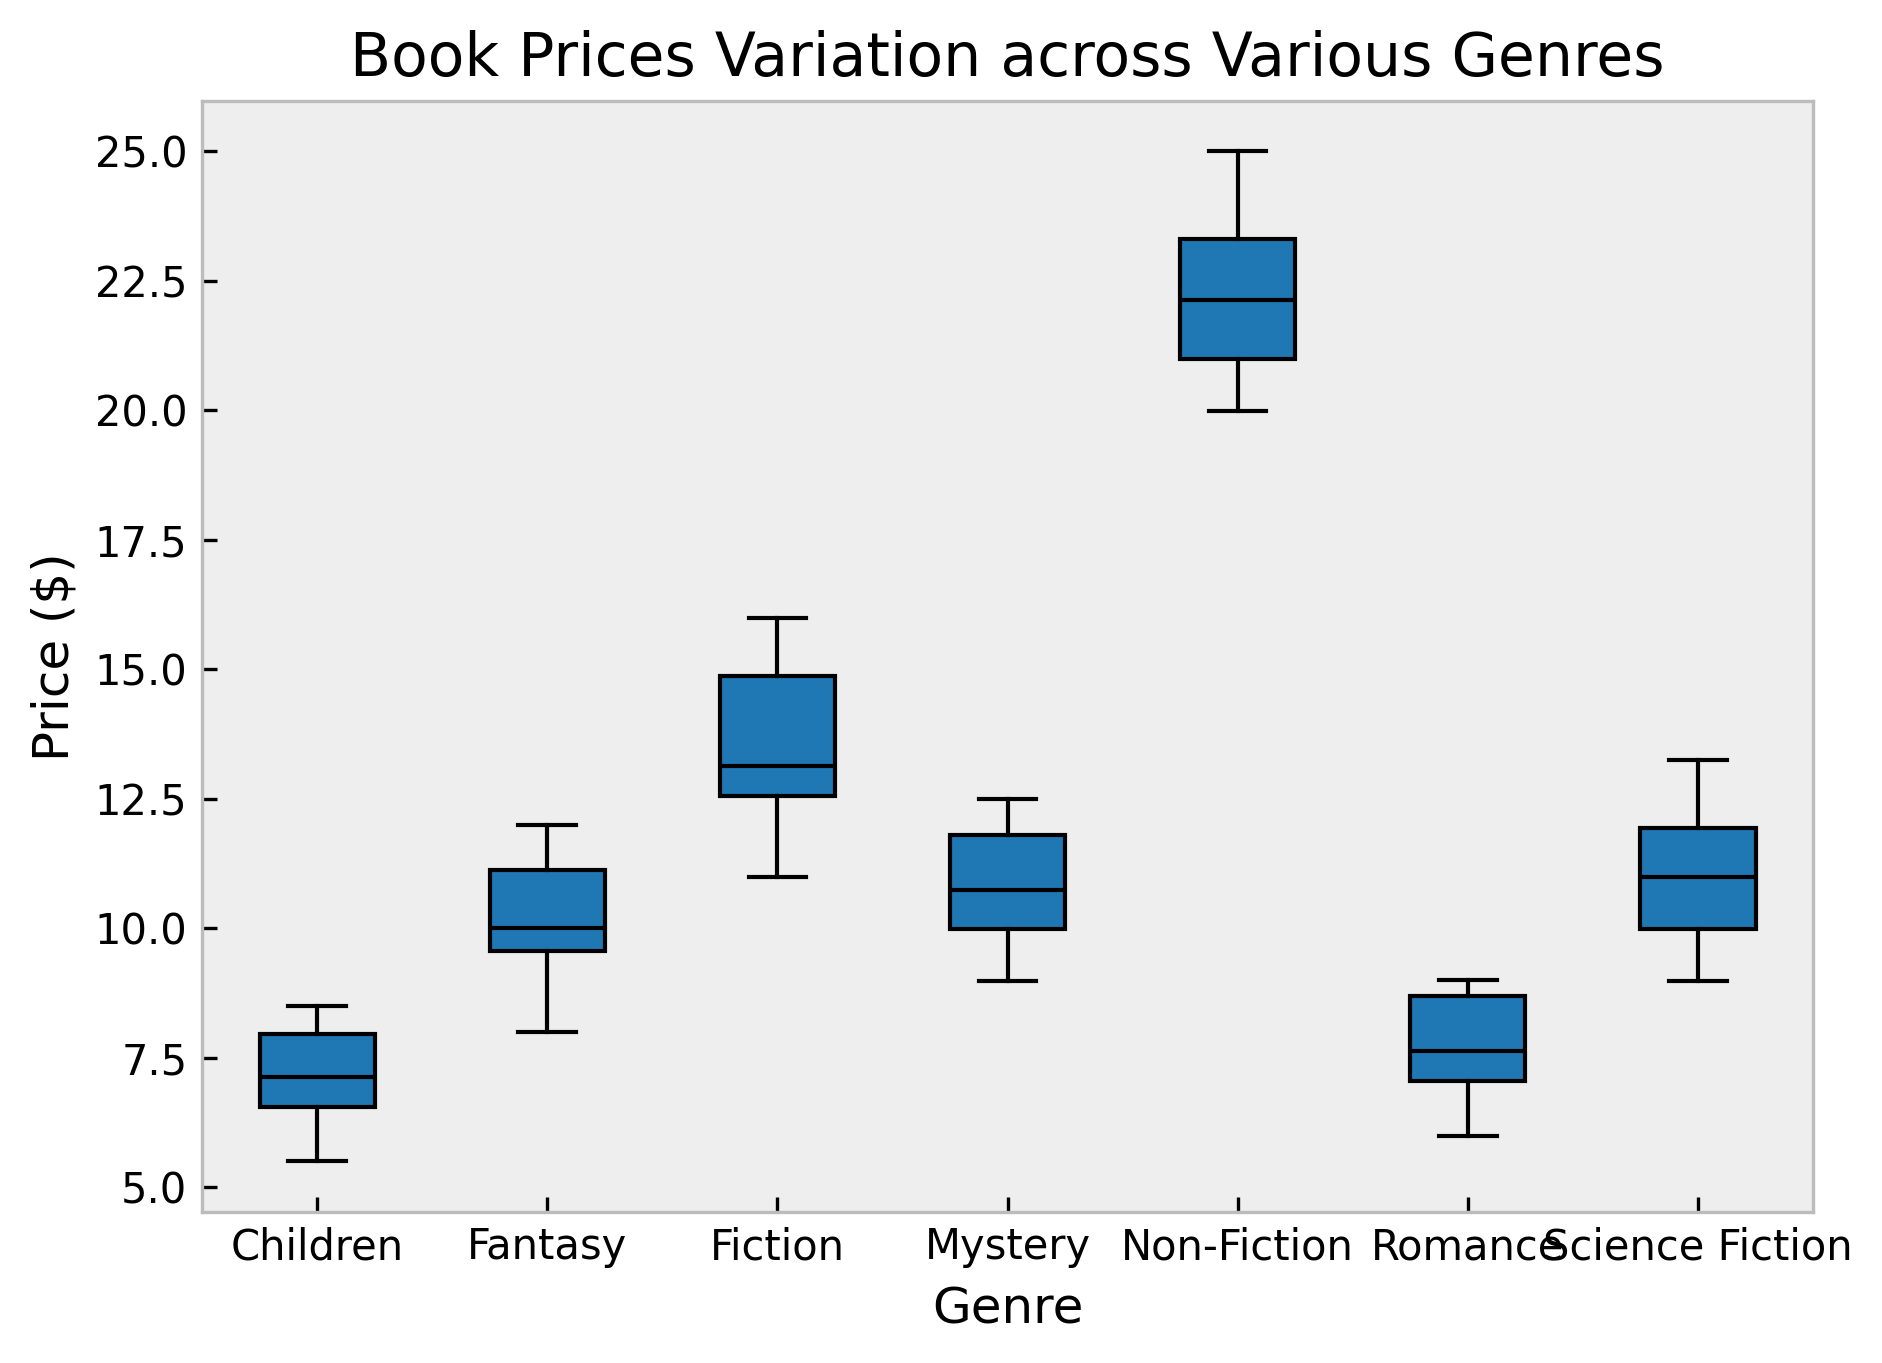What is the median price of children's books? The median price is the middle value of a sorted list of numbers. For children's books, sort the prices and find the middle value. The sorted prices are 5.50, 5.99, 6.49, 6.75, 6.99, 7.25, 7.85, 7.99, 8.00, 8.50. The median value is between the 5th and 6th values: (6.99 + 7.25) / 2 = 7.12.
Answer: 7.12 Which genre has the highest median book price? To find the highest median book price, look at the middle line of each box, which represents the median. For Non-Fiction, the line is highest, indicating the highest median price.
Answer: Non-Fiction Compare the range of book prices for Mystery and Fantasy genres. Which one has a greater range? The range is the difference between the maximum and minimum values. For Mystery, range = 12.49 - 8.99 = 3.50. For Fantasy, range = 12.00 - 7.99 = 4.01. Fantasy has a greater range.
Answer: Fantasy Is there any genre with outliers in the book prices? Outliers are often indicated by points outside the whiskers of the box plots. Looking at the figures, no genre shows outliers (points outside the main box plot range).
Answer: No What is the interquartile range (IQR) for Fiction books? IQR is calculated by subtracting the first quartile (Q1) from the third quartile (Q3). For Fiction: locate Q1 and Q3 from the box. Q1 is approximately 12.25 and Q3 is about 14.99. So, IQR is (14.99 - 12.25) = 2.74.
Answer: 2.74 Which genre has the smallest variation in book prices? Variation can be visually assessed by the height of the box in the box plot. The shorter the box, the smaller the variation. Children's genre has the shortest box, indicating the smallest variation.
Answer: Children Between Science Fiction and Romance genres, which has a higher maximum price? The maximum price is indicated by the top whisker or edge of the box. For Science Fiction, the top whisker is at 13.25, while for Romance, it is at 9.00. Hence, Science Fiction has a higher maximum price.
Answer: Science Fiction How many genres have a median price greater than $10? Check the middle line (median) of each genre's box in the plot. Genres with median prices above $10 are Fiction, Non-Fiction, Science Fiction, and Mystery. In total, there are 4 genres.
Answer: 4 